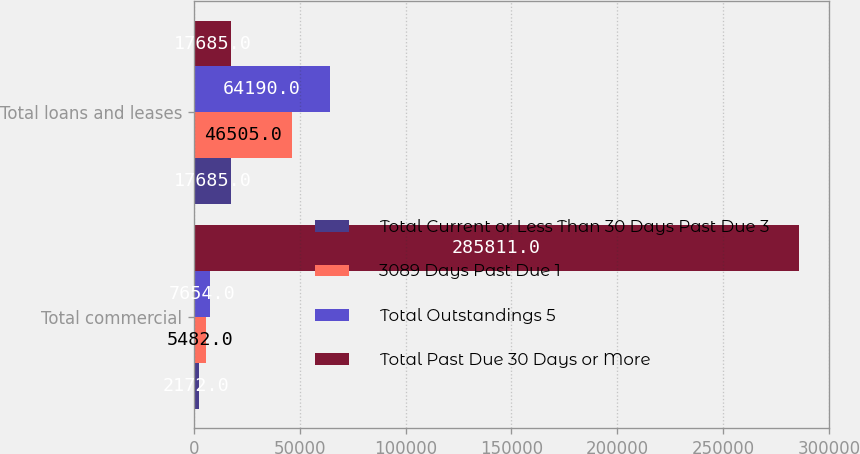<chart> <loc_0><loc_0><loc_500><loc_500><stacked_bar_chart><ecel><fcel>Total commercial<fcel>Total loans and leases<nl><fcel>Total Current or Less Than 30 Days Past Due 3<fcel>2172<fcel>17685<nl><fcel>3089 Days Past Due 1<fcel>5482<fcel>46505<nl><fcel>Total Outstandings 5<fcel>7654<fcel>64190<nl><fcel>Total Past Due 30 Days or More<fcel>285811<fcel>17685<nl></chart> 